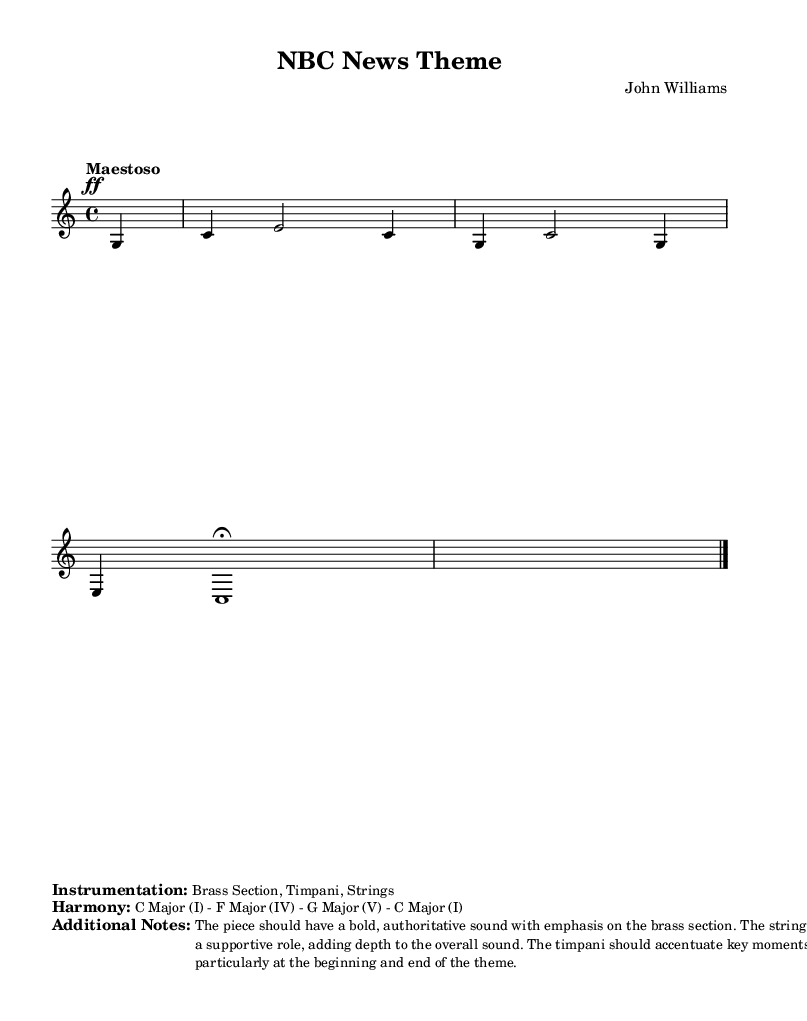What is the key signature of this music? The key signature is C major, which has no sharps or flats indicated at the beginning of the staff.
Answer: C major What is the time signature of this piece? The time signature is found at the beginning of the staff; it indicates four beats per measure, which is written as 4/4.
Answer: 4/4 What is the indicated tempo for this piece? The tempo marking "Maestoso" specifies a slow, dignified pace, and the number "4 = 85" suggests a tempo of 85 beats per minute.
Answer: 85 BPM What instruments are specified in the instrumentation? Analyzing the sheet music, the markup section explicitly lists the instruments used; they include "Brass Section, Timpani, Strings."
Answer: Brass Section, Timpani, Strings Which harmonies are associated with this piece? The harmony section indicates the chord progression; it mentions C Major (I), F Major (IV), G Major (V), and returns to C Major (I).
Answer: C Major, F Major, G Major, C Major How should the dynamics be interpreted in this section? The dynamic marking "ff" indicates a "forte" or loud emphasis at the start, combined with accents on the brass section, which suggests a bold and authoritative sound.
Answer: Forte (ff) What role do the strings play in this composition? The additional notes specify that the strings provide depth, implying they are used to support the brass section rather than being the main focus.
Answer: Supportive role 